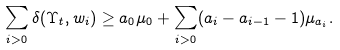Convert formula to latex. <formula><loc_0><loc_0><loc_500><loc_500>\sum _ { i > 0 } \delta ( \Upsilon _ { t } , w _ { i } ) \geq a _ { 0 } \mu _ { 0 } + \sum _ { i > 0 } ( a _ { i } - a _ { i - 1 } - 1 ) \mu _ { a _ { i } } .</formula> 